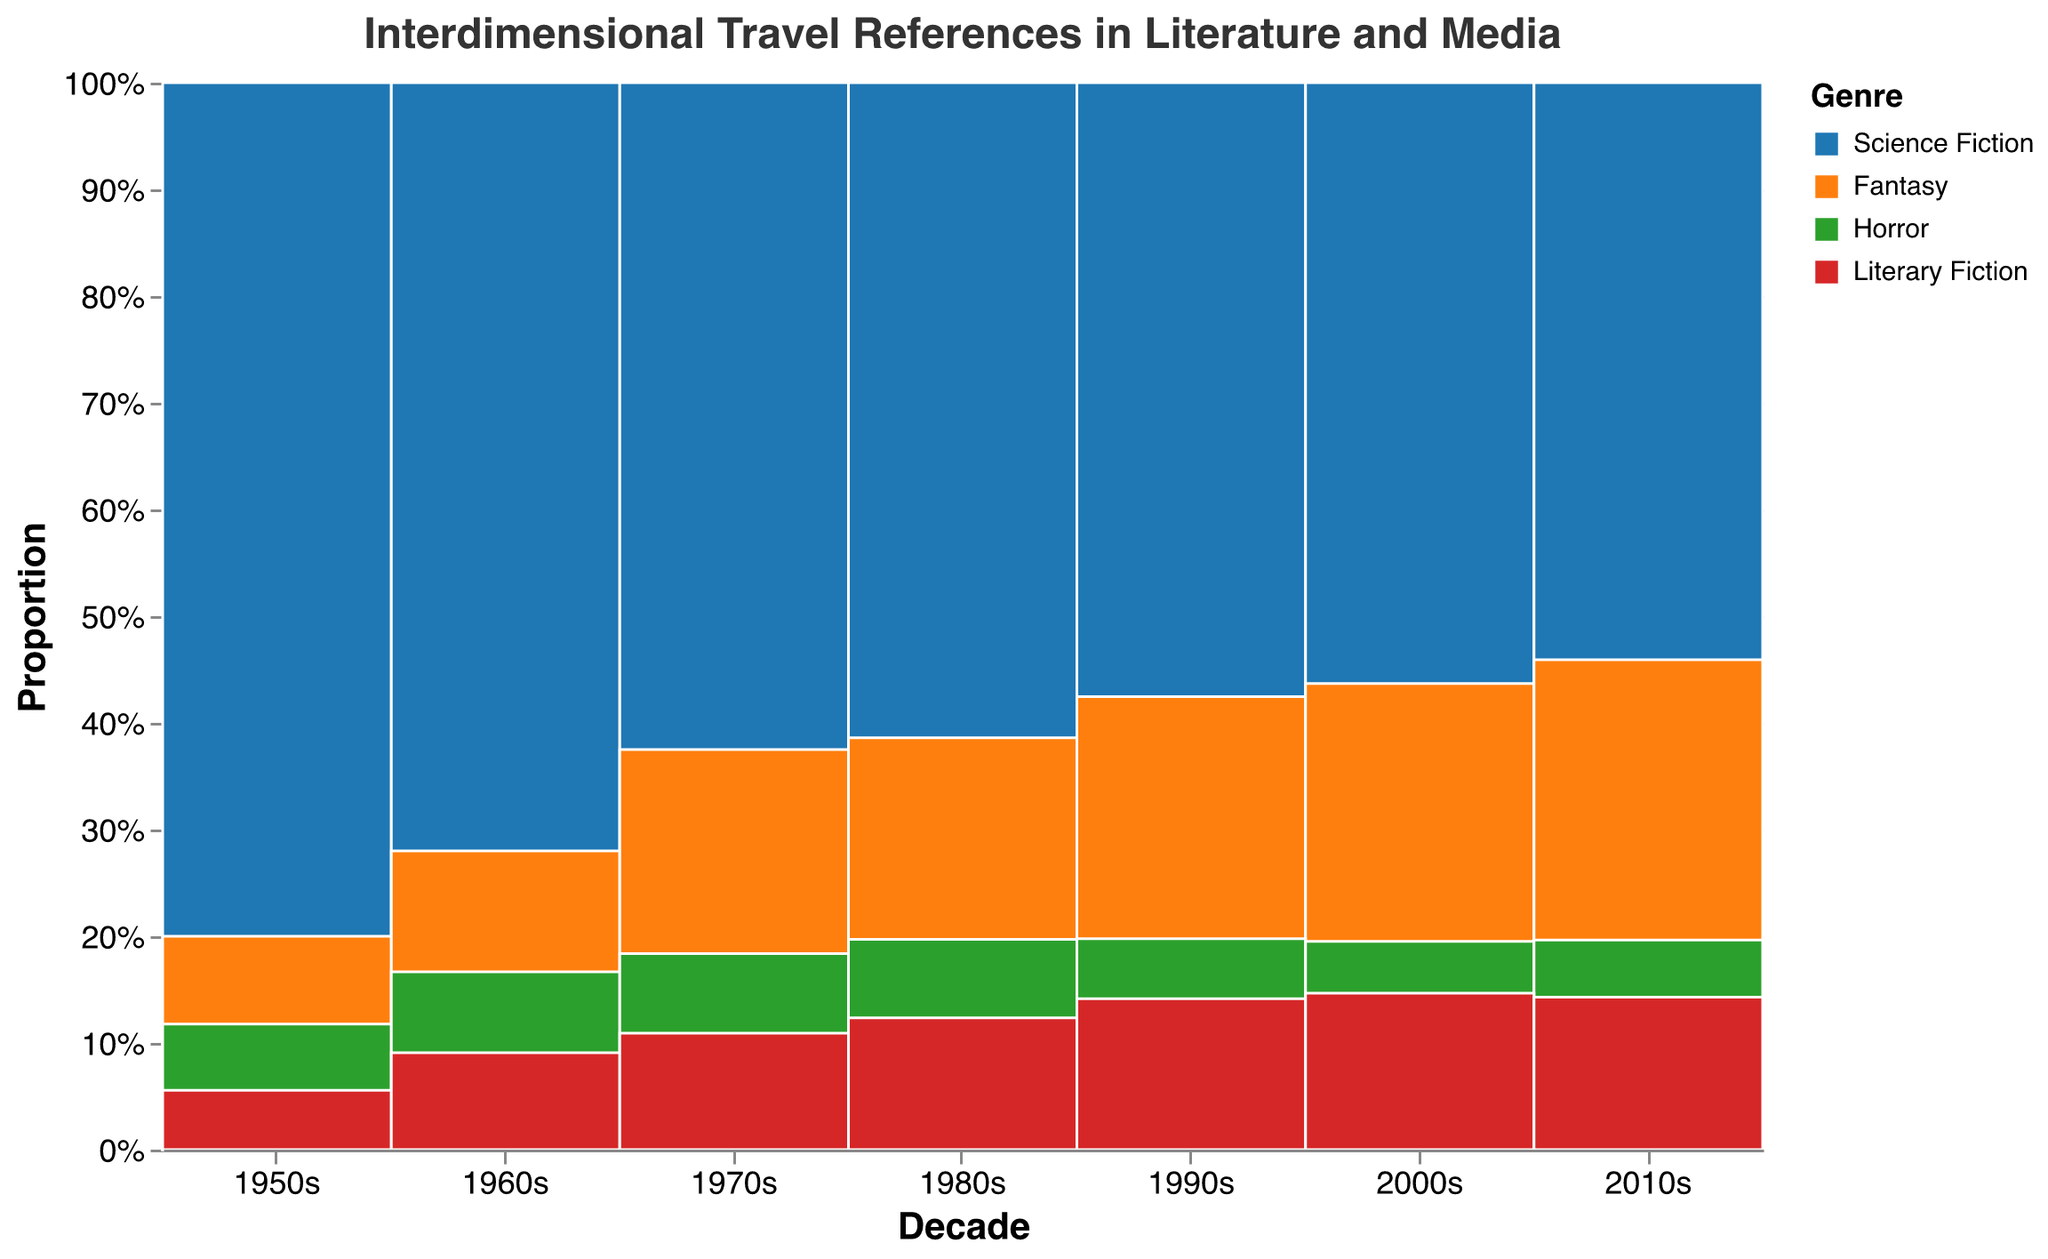What's the most frequently referenced genre in the 2010s? The 2010s decade shows the highest proportion of the Science Fiction genre in the plot. This can be determined by the largest area and color section for the 2010s.
Answer: Science Fiction Which genre had the least amount of references in the 1950s? In the 1950s, the smallest section in the plot belongs to Literary Fiction, indicated by a smaller area in red.
Answer: Literary Fiction How did the proportion of Fantasy change from the 1950s to the 2010s? In the 1950s, Fantasy had a small proportion compared to other genres, but by the 2010s, it significantly increased, demonstrating a growth trend shown by the increasing size of the orange sections in the plot.
Answer: Increased What is the proportion of Horror in the 1980s compared to Science Fiction in the same decade? In the 1980s, Horror has a smaller proportion than Science Fiction. The green section for Horror is noticeably smaller than the blue section for Science Fiction on the plot.
Answer: Smaller Between which decades did Literary Fiction see the most significant increase in references? Literary Fiction shows the most noticeable increase between the 1950s and 2010s. However, a significant jump can be observed between the 1990s and 2000s, as seen from the increase in the red section of the plot.
Answer: 1990s to 2000s Among all genres, which saw the highest increase in references from the 2000s to the 2010s? Science Fiction had the highest increase in the number of references from the 2000s to the 2010s, as demonstrated by the large increase in the blue section between these decades.
Answer: Science Fiction What's the rank of Horror’s references in the 1960s compared to other genres in the same decade? In the 1960s, Horror has more references than Literary Fiction but less than Fantasy and Science Fiction. The green section for Horror is larger than the red section for Literary Fiction but smaller than the orange section for Fantasy and blue section for Science Fiction.
Answer: 3rd By what proportion did Science Fiction increase from 1950s to 2010s? The proportion increased from around 12 references in the 1950s to approximately 73 in the 2010s, translating to an increase relative to the total amount in each decades' references. This change can be visually deduced as the blue section grows significantly larger from 1950s to 2010s.
Answer: Increased significantly Which genre had the highest acceleration in references after the 2000s? After the 2000s, Fantasy genre references increased rapidly, showing one of the highest accelerations in the number of references, as indicated by the steep growth of the orange section in the plot.
Answer: Fantasy 